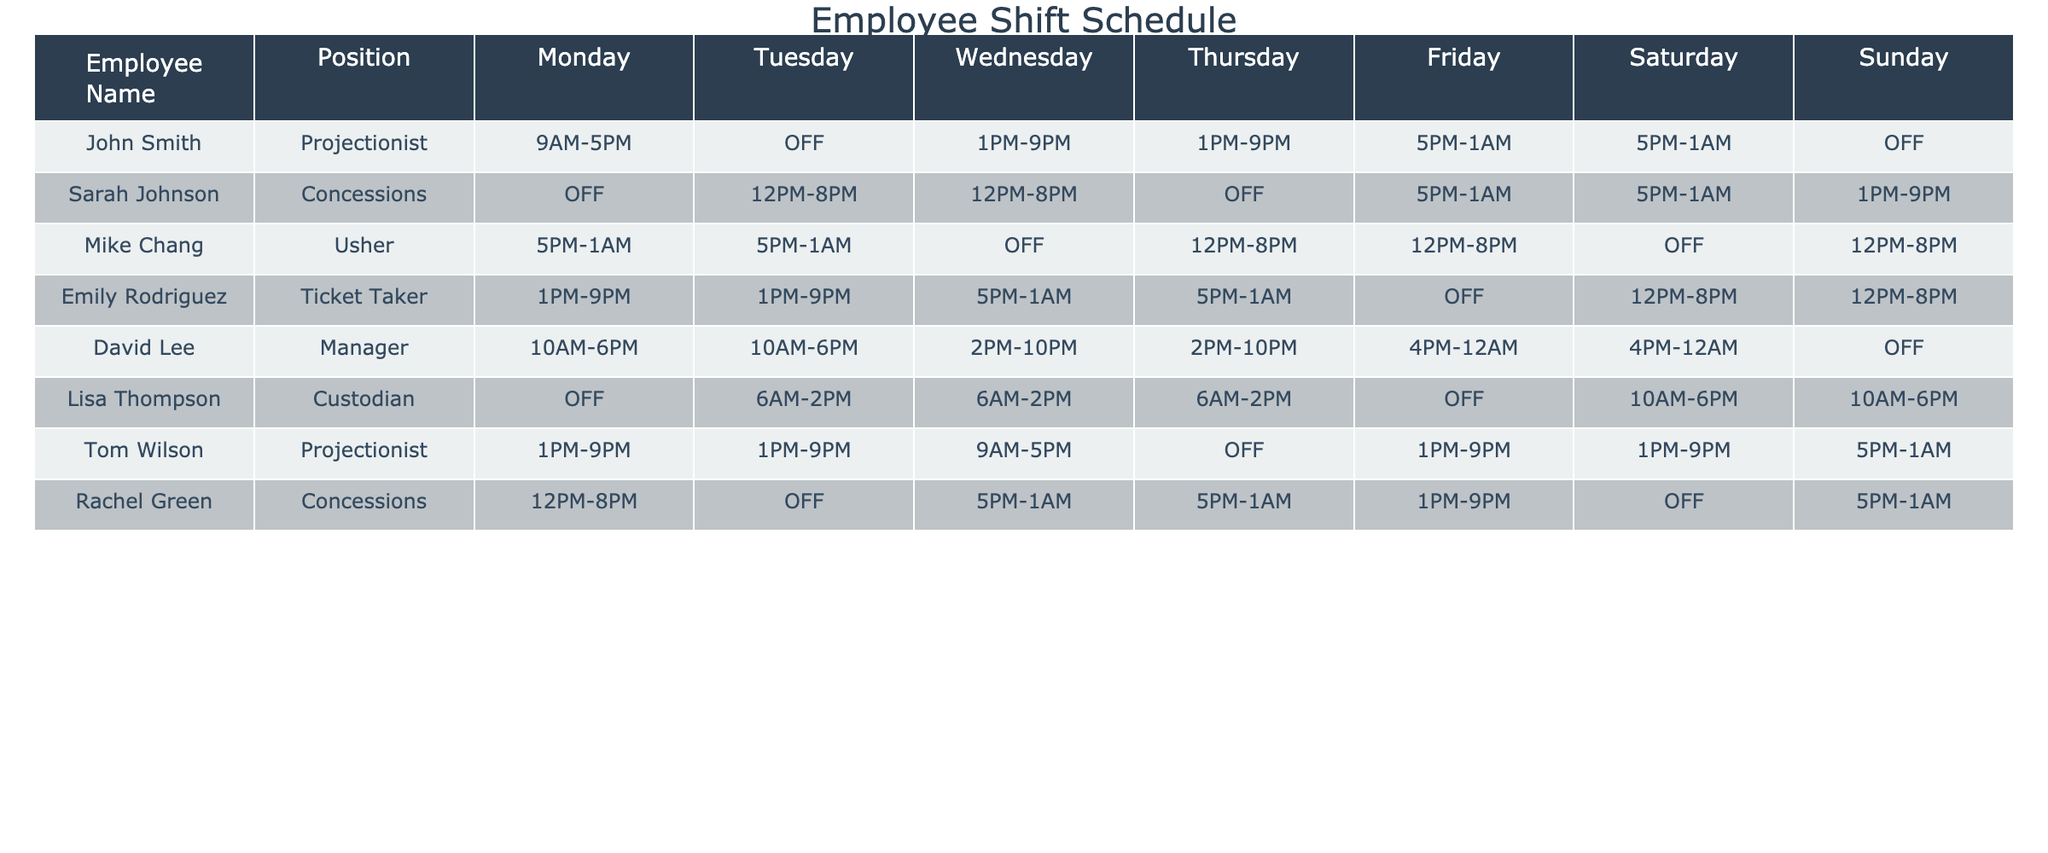What are the working hours of John Smith on Friday? John Smith's Friday shift is listed in the "Friday" column of the table under his row. It shows "5PM-1AM."
Answer: 5PM-1AM How many employees are scheduled to work on Saturday? By reviewing the "Saturday" column, we see that John Smith, Sarah Johnson, Emily Rodriguez, Tom Wilson, and Lisa Thompson are working that day. This totals to 5 employees working on Saturday.
Answer: 5 Is Rachel Green working on Tuesday? By checking the "Tuesday" column for Rachel Green, it shows "OFF." Therefore, she is not working on Tuesday.
Answer: No What is the total number of shifts for the position of Projectionist in a week? The table shows John Smith and Tom Wilson as Projectionists. John Smith works 5 shifts (Monday, Wednesday, Thursday, Friday, Saturday) and Tom Wilson works 5 shifts (Monday, Tuesday, Wednesday, Friday, Saturday). Adding these gives 5 + 5 = 10 shifts for Projectionists in total.
Answer: 10 Which employee has the most consecutive days off? By reviewing each employee’s shifts, Lisa Thompson has two consecutive days off (Monday is OFF and then Tuesday is 6AM-2PM). On her row, it confirms that she has no shifts on Monday.
Answer: Lisa Thompson How many total shifts does Sarah Johnson have in a week? Looking at the "Monday" through "Sunday" columns for Sarah Johnson, she is scheduled for a total of 5 shifts (Tuesday, Wednesday, Friday, Saturday, Sunday) since she is OFF on Monday. Therefore, her total is 5 shifts.
Answer: 5 Are there any employees that work more than one shift on a single day? By reviewing all employees' shifts, David Lee works 2 shifts on Friday (4PM-12AM) and Saturday (4PM-12AM). He is the only one confirmed to have more than one shift in a day.
Answer: Yes What is the average number of hours worked by the ticket taker over the week? Emily Rodriguez works 5 shifts. Assuming each shift is 8 hours (from the data provided), she works 5 shifts x 8 hours = 40 hours. When averaging this over 7 days, the average is 40/7 which equals approximately 5.71 hours per day.
Answer: 5.71 